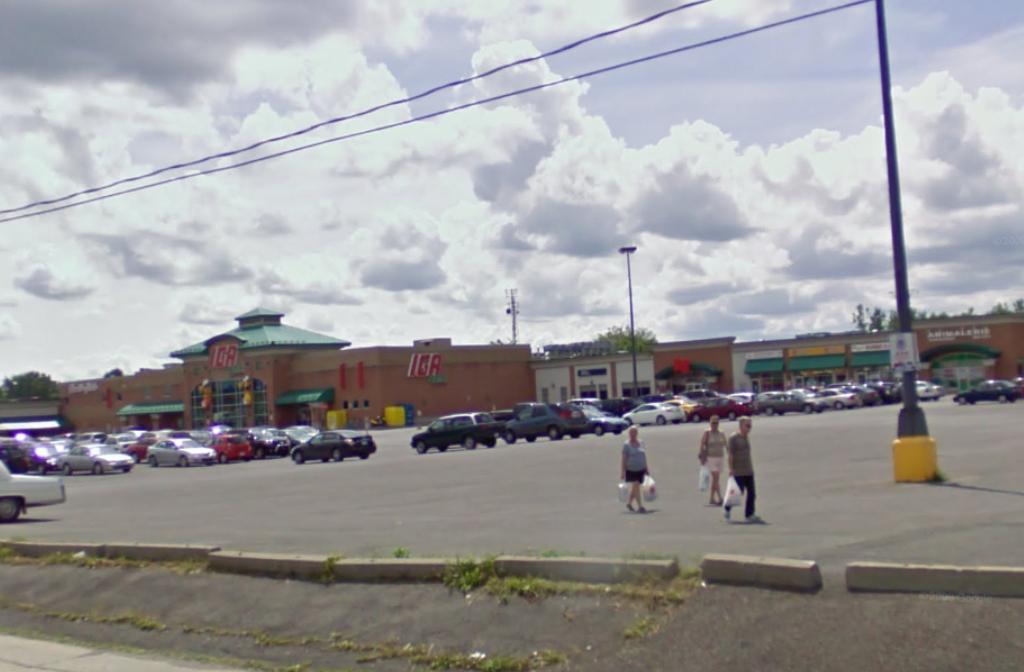What store are all these cars parked in front of?
Provide a short and direct response. Iga. 